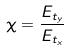<formula> <loc_0><loc_0><loc_500><loc_500>\chi = \frac { E _ { t _ { y } } } { E _ { t _ { x } } }</formula> 